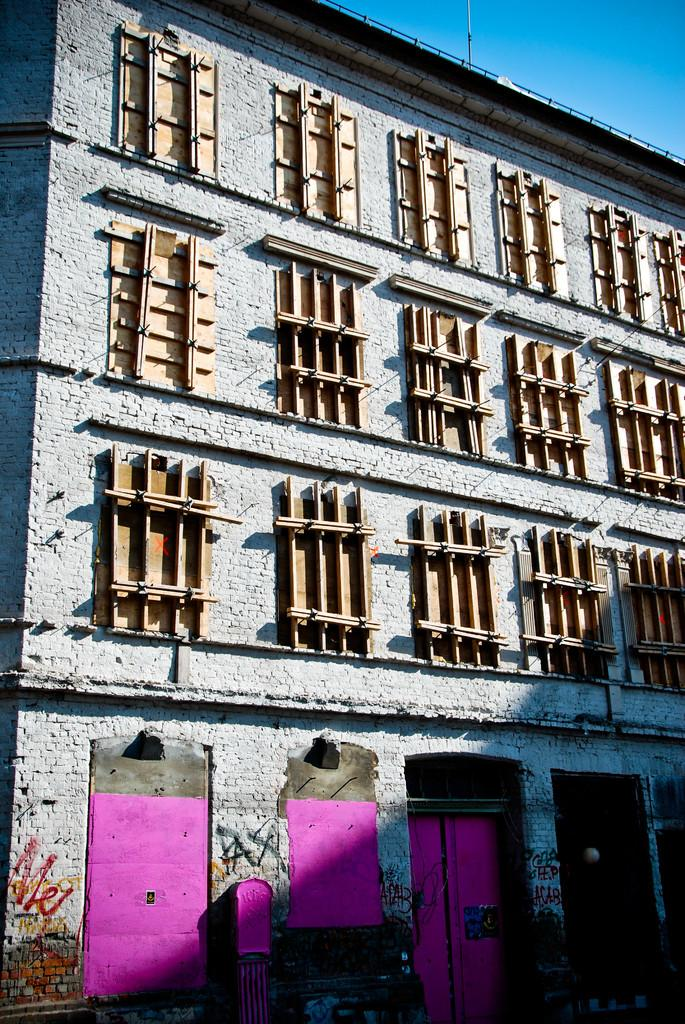What type of structure is present in the image? There is a building in the image. What can be observed about the windows of the building? The building has many closed windows. What feature is present at the bottom of the building? There are doors at the bottom of the building. What can be seen in the background of the image? The sky is visible in the background of the image. What type of company is represented by the badge on the building in the image? There is no badge present on the building in the image. How many rails are visible on the building in the image? There are no rails visible on the building in the image. 